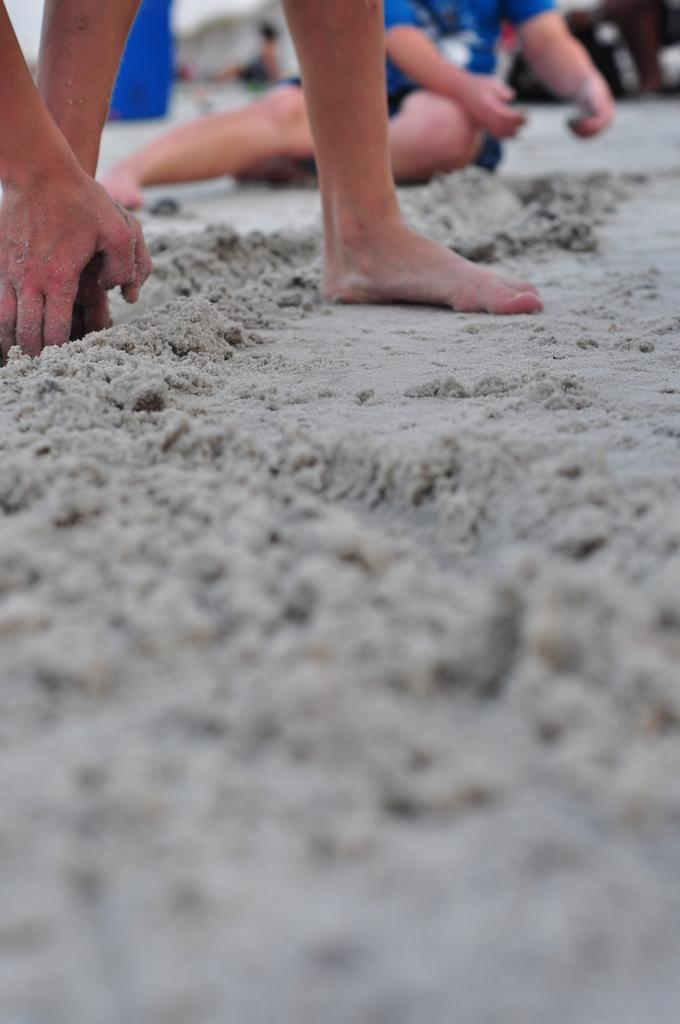What body parts of people can be seen in the image? There are people's legs and hands visible in the image. What type of terrain is present in the image? There is sand in the image. How would you describe the background of the image? The background of the image is blurry. Can you identify any other people in the image besides the ones with visible legs and hands? Yes, there is a person sitting in the background of the image. What type of zinc is being used to create the example in the image? There is no zinc or example present in the image; it features people's legs and hands in a sandy environment with a blurry background. 